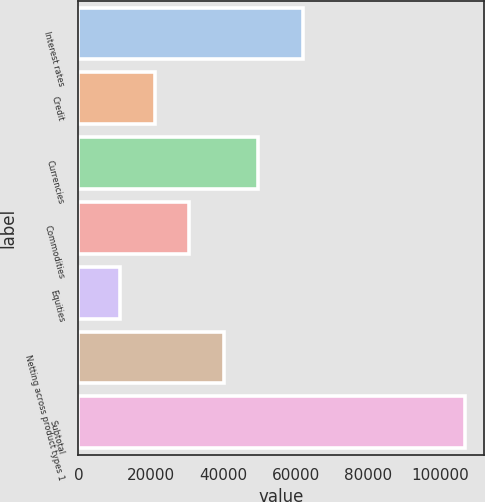Convert chart to OTSL. <chart><loc_0><loc_0><loc_500><loc_500><bar_chart><fcel>Interest rates<fcel>Credit<fcel>Currencies<fcel>Commodities<fcel>Equities<fcel>Netting across product types 1<fcel>Subtotal<nl><fcel>62133<fcel>21065.8<fcel>49601.2<fcel>30577.6<fcel>11554<fcel>40089.4<fcel>106672<nl></chart> 